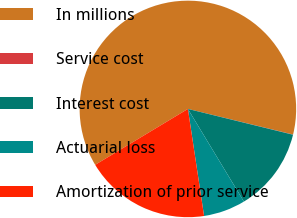Convert chart to OTSL. <chart><loc_0><loc_0><loc_500><loc_500><pie_chart><fcel>In millions<fcel>Service cost<fcel>Interest cost<fcel>Actuarial loss<fcel>Amortization of prior service<nl><fcel>62.43%<fcel>0.03%<fcel>12.51%<fcel>6.27%<fcel>18.75%<nl></chart> 